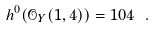<formula> <loc_0><loc_0><loc_500><loc_500>h ^ { 0 } ( \mathcal { O } _ { Y } ( 1 , 4 ) ) = 1 0 4 \ .</formula> 